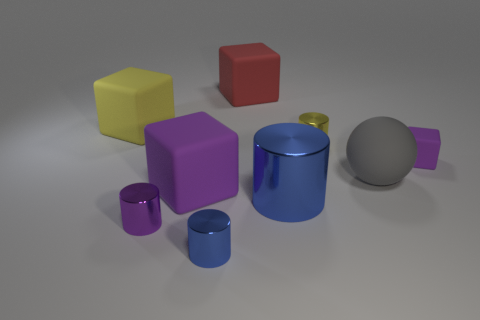What is the shape of the tiny object that is the same color as the big metal cylinder?
Your response must be concise. Cylinder. The small purple thing on the right side of the large purple thing has what shape?
Offer a very short reply. Cube. How many purple objects are matte blocks or big spheres?
Your response must be concise. 2. Does the big purple object have the same material as the large red thing?
Keep it short and to the point. Yes. What number of big cylinders are behind the small yellow metallic cylinder?
Provide a short and direct response. 0. What is the material of the tiny thing that is both behind the tiny purple shiny thing and in front of the small yellow metallic object?
Give a very brief answer. Rubber. How many cylinders are either yellow things or blue things?
Give a very brief answer. 3. There is a tiny purple object that is the same shape as the large red matte thing; what is it made of?
Give a very brief answer. Rubber. The yellow thing that is the same material as the large red cube is what size?
Your response must be concise. Large. There is a small purple thing that is on the left side of the tiny rubber block; is its shape the same as the large object that is in front of the large purple rubber cube?
Provide a short and direct response. Yes. 